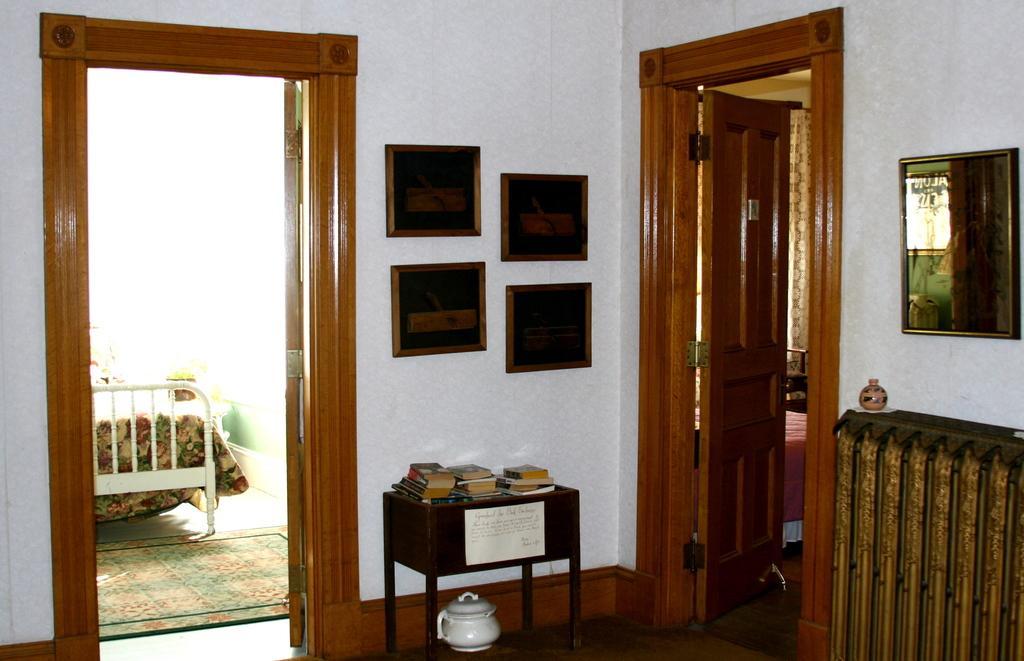Could you give a brief overview of what you see in this image? In this picture we can see a room, on the left side there is a bed, we can see a table in the middle, there are some books on the table, on the right side there is a mirror, we can see photo frames on the wall, on the right side there is a door. 